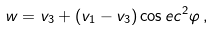Convert formula to latex. <formula><loc_0><loc_0><loc_500><loc_500>w = v _ { 3 } + ( v _ { 1 } - v _ { 3 } ) \cos e c ^ { 2 } \varphi \, ,</formula> 